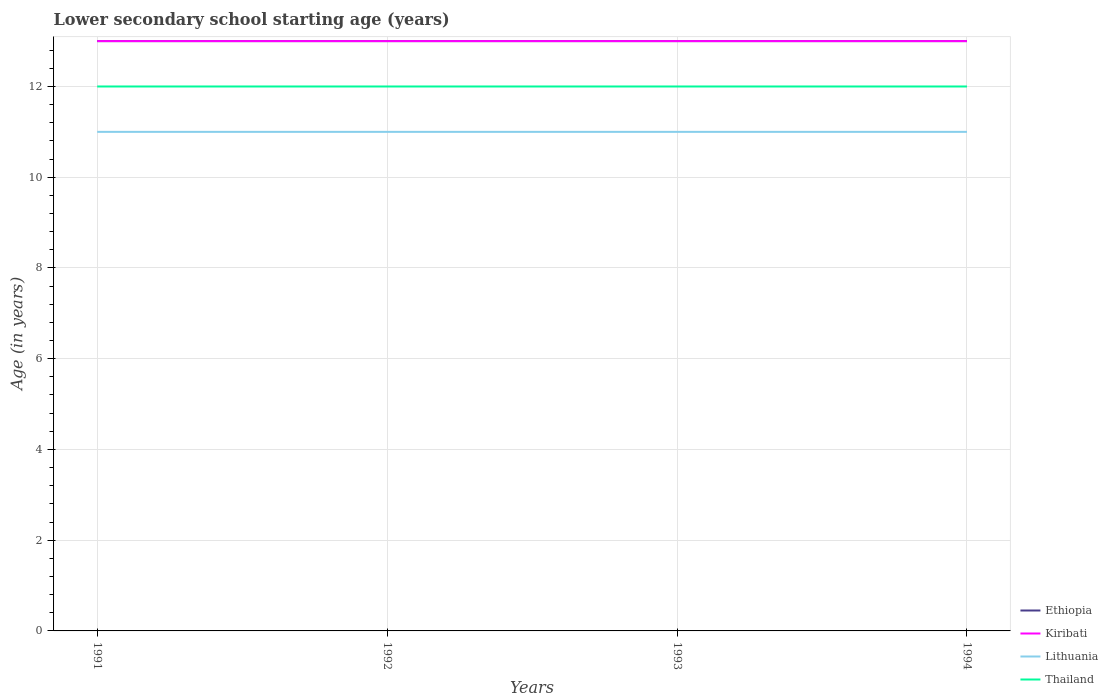How many different coloured lines are there?
Keep it short and to the point. 4. Across all years, what is the maximum lower secondary school starting age of children in Ethiopia?
Offer a very short reply. 13. In which year was the lower secondary school starting age of children in Ethiopia maximum?
Your answer should be compact. 1991. What is the difference between the highest and the second highest lower secondary school starting age of children in Thailand?
Provide a succinct answer. 0. Is the lower secondary school starting age of children in Lithuania strictly greater than the lower secondary school starting age of children in Ethiopia over the years?
Ensure brevity in your answer.  Yes. How many lines are there?
Offer a terse response. 4. How many years are there in the graph?
Your answer should be compact. 4. What is the difference between two consecutive major ticks on the Y-axis?
Offer a very short reply. 2. Does the graph contain grids?
Offer a very short reply. Yes. Where does the legend appear in the graph?
Keep it short and to the point. Bottom right. What is the title of the graph?
Offer a very short reply. Lower secondary school starting age (years). What is the label or title of the Y-axis?
Make the answer very short. Age (in years). What is the Age (in years) in Kiribati in 1991?
Your answer should be compact. 13. What is the Age (in years) in Thailand in 1991?
Make the answer very short. 12. What is the Age (in years) of Ethiopia in 1992?
Give a very brief answer. 13. What is the Age (in years) of Kiribati in 1992?
Provide a short and direct response. 13. What is the Age (in years) of Lithuania in 1992?
Offer a terse response. 11. What is the Age (in years) of Thailand in 1992?
Make the answer very short. 12. What is the Age (in years) in Ethiopia in 1993?
Provide a short and direct response. 13. What is the Age (in years) of Thailand in 1993?
Provide a short and direct response. 12. What is the Age (in years) of Ethiopia in 1994?
Offer a terse response. 13. What is the Age (in years) in Thailand in 1994?
Keep it short and to the point. 12. Across all years, what is the maximum Age (in years) of Ethiopia?
Your response must be concise. 13. Across all years, what is the maximum Age (in years) in Kiribati?
Keep it short and to the point. 13. Across all years, what is the maximum Age (in years) in Lithuania?
Ensure brevity in your answer.  11. Across all years, what is the minimum Age (in years) in Lithuania?
Your answer should be compact. 11. Across all years, what is the minimum Age (in years) of Thailand?
Provide a short and direct response. 12. What is the total Age (in years) of Lithuania in the graph?
Keep it short and to the point. 44. What is the difference between the Age (in years) of Kiribati in 1991 and that in 1992?
Provide a succinct answer. 0. What is the difference between the Age (in years) of Kiribati in 1991 and that in 1993?
Your answer should be compact. 0. What is the difference between the Age (in years) of Lithuania in 1991 and that in 1993?
Offer a terse response. 0. What is the difference between the Age (in years) of Thailand in 1991 and that in 1993?
Make the answer very short. 0. What is the difference between the Age (in years) of Lithuania in 1991 and that in 1994?
Keep it short and to the point. 0. What is the difference between the Age (in years) of Thailand in 1991 and that in 1994?
Your answer should be compact. 0. What is the difference between the Age (in years) of Kiribati in 1992 and that in 1993?
Offer a very short reply. 0. What is the difference between the Age (in years) of Ethiopia in 1992 and that in 1994?
Offer a very short reply. 0. What is the difference between the Age (in years) of Kiribati in 1992 and that in 1994?
Your response must be concise. 0. What is the difference between the Age (in years) of Lithuania in 1992 and that in 1994?
Give a very brief answer. 0. What is the difference between the Age (in years) in Ethiopia in 1993 and that in 1994?
Your answer should be very brief. 0. What is the difference between the Age (in years) of Kiribati in 1993 and that in 1994?
Provide a succinct answer. 0. What is the difference between the Age (in years) of Thailand in 1993 and that in 1994?
Provide a short and direct response. 0. What is the difference between the Age (in years) of Ethiopia in 1991 and the Age (in years) of Lithuania in 1992?
Your answer should be compact. 2. What is the difference between the Age (in years) in Ethiopia in 1991 and the Age (in years) in Thailand in 1992?
Your answer should be very brief. 1. What is the difference between the Age (in years) in Kiribati in 1991 and the Age (in years) in Lithuania in 1992?
Your response must be concise. 2. What is the difference between the Age (in years) of Ethiopia in 1991 and the Age (in years) of Kiribati in 1993?
Your answer should be compact. 0. What is the difference between the Age (in years) of Ethiopia in 1991 and the Age (in years) of Lithuania in 1993?
Your answer should be compact. 2. What is the difference between the Age (in years) in Ethiopia in 1991 and the Age (in years) in Thailand in 1993?
Your answer should be compact. 1. What is the difference between the Age (in years) of Kiribati in 1991 and the Age (in years) of Thailand in 1993?
Provide a short and direct response. 1. What is the difference between the Age (in years) in Lithuania in 1991 and the Age (in years) in Thailand in 1993?
Your answer should be compact. -1. What is the difference between the Age (in years) in Ethiopia in 1991 and the Age (in years) in Thailand in 1994?
Provide a succinct answer. 1. What is the difference between the Age (in years) of Kiribati in 1991 and the Age (in years) of Lithuania in 1994?
Your response must be concise. 2. What is the difference between the Age (in years) of Ethiopia in 1992 and the Age (in years) of Thailand in 1993?
Keep it short and to the point. 1. What is the difference between the Age (in years) in Kiribati in 1992 and the Age (in years) in Lithuania in 1993?
Provide a succinct answer. 2. What is the difference between the Age (in years) in Lithuania in 1992 and the Age (in years) in Thailand in 1993?
Provide a short and direct response. -1. What is the difference between the Age (in years) in Ethiopia in 1992 and the Age (in years) in Lithuania in 1994?
Make the answer very short. 2. What is the difference between the Age (in years) of Ethiopia in 1992 and the Age (in years) of Thailand in 1994?
Offer a terse response. 1. What is the difference between the Age (in years) of Kiribati in 1992 and the Age (in years) of Lithuania in 1994?
Give a very brief answer. 2. What is the difference between the Age (in years) in Lithuania in 1992 and the Age (in years) in Thailand in 1994?
Give a very brief answer. -1. What is the difference between the Age (in years) of Ethiopia in 1993 and the Age (in years) of Kiribati in 1994?
Your answer should be compact. 0. What is the difference between the Age (in years) of Kiribati in 1993 and the Age (in years) of Lithuania in 1994?
Provide a succinct answer. 2. What is the difference between the Age (in years) in Lithuania in 1993 and the Age (in years) in Thailand in 1994?
Provide a succinct answer. -1. In the year 1991, what is the difference between the Age (in years) in Ethiopia and Age (in years) in Lithuania?
Keep it short and to the point. 2. In the year 1991, what is the difference between the Age (in years) in Ethiopia and Age (in years) in Thailand?
Offer a very short reply. 1. In the year 1991, what is the difference between the Age (in years) in Lithuania and Age (in years) in Thailand?
Make the answer very short. -1. In the year 1992, what is the difference between the Age (in years) of Ethiopia and Age (in years) of Lithuania?
Offer a very short reply. 2. In the year 1992, what is the difference between the Age (in years) of Kiribati and Age (in years) of Thailand?
Provide a succinct answer. 1. In the year 1992, what is the difference between the Age (in years) of Lithuania and Age (in years) of Thailand?
Provide a succinct answer. -1. In the year 1993, what is the difference between the Age (in years) in Ethiopia and Age (in years) in Kiribati?
Offer a terse response. 0. In the year 1993, what is the difference between the Age (in years) in Ethiopia and Age (in years) in Thailand?
Offer a terse response. 1. In the year 1994, what is the difference between the Age (in years) of Ethiopia and Age (in years) of Lithuania?
Offer a very short reply. 2. What is the ratio of the Age (in years) in Lithuania in 1991 to that in 1992?
Give a very brief answer. 1. What is the ratio of the Age (in years) in Thailand in 1991 to that in 1992?
Give a very brief answer. 1. What is the ratio of the Age (in years) in Ethiopia in 1991 to that in 1993?
Provide a succinct answer. 1. What is the ratio of the Age (in years) of Thailand in 1991 to that in 1993?
Offer a terse response. 1. What is the ratio of the Age (in years) in Ethiopia in 1991 to that in 1994?
Offer a terse response. 1. What is the ratio of the Age (in years) in Ethiopia in 1992 to that in 1993?
Provide a succinct answer. 1. What is the ratio of the Age (in years) in Kiribati in 1992 to that in 1993?
Provide a short and direct response. 1. What is the ratio of the Age (in years) in Lithuania in 1992 to that in 1993?
Your answer should be compact. 1. What is the ratio of the Age (in years) of Thailand in 1992 to that in 1993?
Keep it short and to the point. 1. What is the ratio of the Age (in years) of Ethiopia in 1992 to that in 1994?
Your response must be concise. 1. What is the ratio of the Age (in years) in Kiribati in 1992 to that in 1994?
Give a very brief answer. 1. What is the ratio of the Age (in years) of Lithuania in 1992 to that in 1994?
Make the answer very short. 1. What is the ratio of the Age (in years) of Thailand in 1992 to that in 1994?
Provide a succinct answer. 1. What is the difference between the highest and the second highest Age (in years) of Ethiopia?
Give a very brief answer. 0. What is the difference between the highest and the second highest Age (in years) in Kiribati?
Make the answer very short. 0. What is the difference between the highest and the second highest Age (in years) of Thailand?
Keep it short and to the point. 0. What is the difference between the highest and the lowest Age (in years) of Ethiopia?
Ensure brevity in your answer.  0. What is the difference between the highest and the lowest Age (in years) of Thailand?
Your response must be concise. 0. 